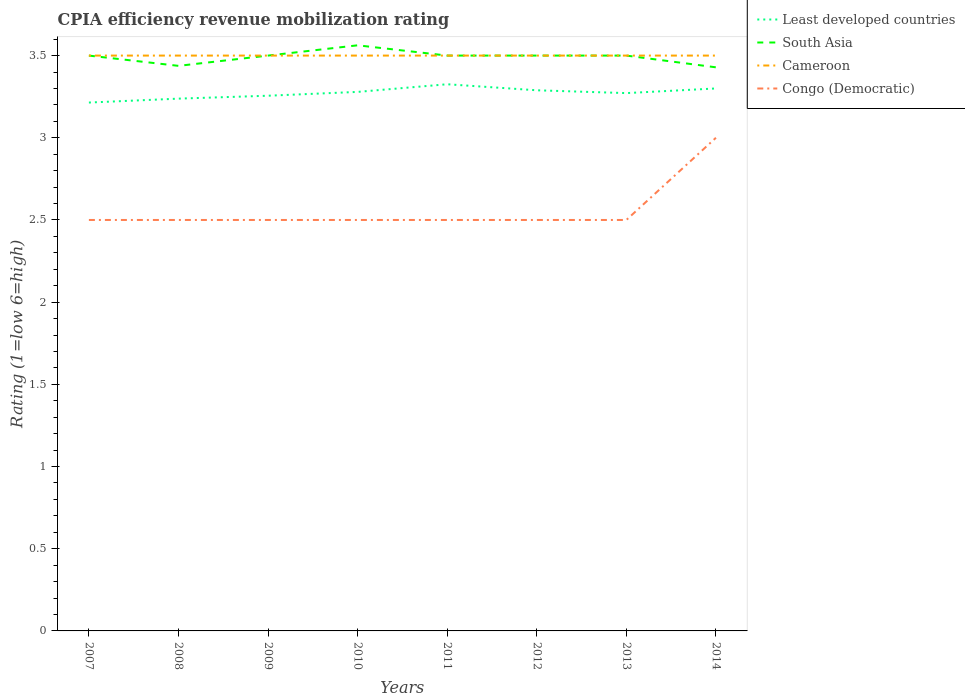Across all years, what is the maximum CPIA rating in Cameroon?
Provide a short and direct response. 3.5. In which year was the CPIA rating in Cameroon maximum?
Ensure brevity in your answer.  2007. What is the total CPIA rating in South Asia in the graph?
Give a very brief answer. 0.06. What is the difference between the highest and the second highest CPIA rating in Least developed countries?
Offer a terse response. 0.11. What is the difference between the highest and the lowest CPIA rating in South Asia?
Keep it short and to the point. 6. Is the CPIA rating in Least developed countries strictly greater than the CPIA rating in Congo (Democratic) over the years?
Provide a succinct answer. No. How many lines are there?
Your answer should be very brief. 4. Does the graph contain any zero values?
Your answer should be very brief. No. How are the legend labels stacked?
Make the answer very short. Vertical. What is the title of the graph?
Make the answer very short. CPIA efficiency revenue mobilization rating. What is the label or title of the X-axis?
Provide a short and direct response. Years. What is the Rating (1=low 6=high) in Least developed countries in 2007?
Give a very brief answer. 3.21. What is the Rating (1=low 6=high) of South Asia in 2007?
Your response must be concise. 3.5. What is the Rating (1=low 6=high) in Cameroon in 2007?
Provide a short and direct response. 3.5. What is the Rating (1=low 6=high) in Congo (Democratic) in 2007?
Make the answer very short. 2.5. What is the Rating (1=low 6=high) in Least developed countries in 2008?
Offer a terse response. 3.24. What is the Rating (1=low 6=high) in South Asia in 2008?
Offer a terse response. 3.44. What is the Rating (1=low 6=high) in Least developed countries in 2009?
Make the answer very short. 3.26. What is the Rating (1=low 6=high) of South Asia in 2009?
Offer a terse response. 3.5. What is the Rating (1=low 6=high) in Least developed countries in 2010?
Offer a terse response. 3.28. What is the Rating (1=low 6=high) in South Asia in 2010?
Your response must be concise. 3.56. What is the Rating (1=low 6=high) of Congo (Democratic) in 2010?
Offer a terse response. 2.5. What is the Rating (1=low 6=high) in Least developed countries in 2011?
Ensure brevity in your answer.  3.33. What is the Rating (1=low 6=high) in South Asia in 2011?
Keep it short and to the point. 3.5. What is the Rating (1=low 6=high) in Cameroon in 2011?
Provide a short and direct response. 3.5. What is the Rating (1=low 6=high) of Congo (Democratic) in 2011?
Make the answer very short. 2.5. What is the Rating (1=low 6=high) of Least developed countries in 2012?
Give a very brief answer. 3.29. What is the Rating (1=low 6=high) in Cameroon in 2012?
Provide a succinct answer. 3.5. What is the Rating (1=low 6=high) of Least developed countries in 2013?
Keep it short and to the point. 3.27. What is the Rating (1=low 6=high) of South Asia in 2013?
Keep it short and to the point. 3.5. What is the Rating (1=low 6=high) in Least developed countries in 2014?
Your response must be concise. 3.3. What is the Rating (1=low 6=high) of South Asia in 2014?
Provide a succinct answer. 3.43. What is the Rating (1=low 6=high) of Cameroon in 2014?
Your answer should be compact. 3.5. What is the Rating (1=low 6=high) in Congo (Democratic) in 2014?
Offer a very short reply. 3. Across all years, what is the maximum Rating (1=low 6=high) of Least developed countries?
Give a very brief answer. 3.33. Across all years, what is the maximum Rating (1=low 6=high) of South Asia?
Your answer should be very brief. 3.56. Across all years, what is the minimum Rating (1=low 6=high) of Least developed countries?
Provide a succinct answer. 3.21. Across all years, what is the minimum Rating (1=low 6=high) of South Asia?
Your answer should be very brief. 3.43. Across all years, what is the minimum Rating (1=low 6=high) in Cameroon?
Offer a terse response. 3.5. What is the total Rating (1=low 6=high) of Least developed countries in the graph?
Your response must be concise. 26.17. What is the total Rating (1=low 6=high) of South Asia in the graph?
Offer a very short reply. 27.93. What is the total Rating (1=low 6=high) of Cameroon in the graph?
Keep it short and to the point. 28. What is the total Rating (1=low 6=high) of Congo (Democratic) in the graph?
Ensure brevity in your answer.  20.5. What is the difference between the Rating (1=low 6=high) of Least developed countries in 2007 and that in 2008?
Keep it short and to the point. -0.02. What is the difference between the Rating (1=low 6=high) in South Asia in 2007 and that in 2008?
Your answer should be compact. 0.06. What is the difference between the Rating (1=low 6=high) of Least developed countries in 2007 and that in 2009?
Ensure brevity in your answer.  -0.04. What is the difference between the Rating (1=low 6=high) in Least developed countries in 2007 and that in 2010?
Your answer should be compact. -0.06. What is the difference between the Rating (1=low 6=high) in South Asia in 2007 and that in 2010?
Offer a very short reply. -0.06. What is the difference between the Rating (1=low 6=high) of Cameroon in 2007 and that in 2010?
Your answer should be very brief. 0. What is the difference between the Rating (1=low 6=high) in Congo (Democratic) in 2007 and that in 2010?
Keep it short and to the point. 0. What is the difference between the Rating (1=low 6=high) in Least developed countries in 2007 and that in 2011?
Offer a terse response. -0.11. What is the difference between the Rating (1=low 6=high) of Cameroon in 2007 and that in 2011?
Provide a succinct answer. 0. What is the difference between the Rating (1=low 6=high) of Congo (Democratic) in 2007 and that in 2011?
Make the answer very short. 0. What is the difference between the Rating (1=low 6=high) in Least developed countries in 2007 and that in 2012?
Give a very brief answer. -0.07. What is the difference between the Rating (1=low 6=high) in South Asia in 2007 and that in 2012?
Make the answer very short. 0. What is the difference between the Rating (1=low 6=high) of Cameroon in 2007 and that in 2012?
Your answer should be compact. 0. What is the difference between the Rating (1=low 6=high) of Congo (Democratic) in 2007 and that in 2012?
Keep it short and to the point. 0. What is the difference between the Rating (1=low 6=high) of Least developed countries in 2007 and that in 2013?
Your response must be concise. -0.06. What is the difference between the Rating (1=low 6=high) in Cameroon in 2007 and that in 2013?
Offer a terse response. 0. What is the difference between the Rating (1=low 6=high) of Congo (Democratic) in 2007 and that in 2013?
Offer a very short reply. 0. What is the difference between the Rating (1=low 6=high) in Least developed countries in 2007 and that in 2014?
Give a very brief answer. -0.09. What is the difference between the Rating (1=low 6=high) of South Asia in 2007 and that in 2014?
Your answer should be very brief. 0.07. What is the difference between the Rating (1=low 6=high) of Cameroon in 2007 and that in 2014?
Keep it short and to the point. 0. What is the difference between the Rating (1=low 6=high) of Least developed countries in 2008 and that in 2009?
Provide a succinct answer. -0.02. What is the difference between the Rating (1=low 6=high) of South Asia in 2008 and that in 2009?
Your answer should be very brief. -0.06. What is the difference between the Rating (1=low 6=high) in Cameroon in 2008 and that in 2009?
Your response must be concise. 0. What is the difference between the Rating (1=low 6=high) in Congo (Democratic) in 2008 and that in 2009?
Ensure brevity in your answer.  0. What is the difference between the Rating (1=low 6=high) in Least developed countries in 2008 and that in 2010?
Provide a short and direct response. -0.04. What is the difference between the Rating (1=low 6=high) of South Asia in 2008 and that in 2010?
Your answer should be very brief. -0.12. What is the difference between the Rating (1=low 6=high) in Least developed countries in 2008 and that in 2011?
Keep it short and to the point. -0.09. What is the difference between the Rating (1=low 6=high) of South Asia in 2008 and that in 2011?
Your response must be concise. -0.06. What is the difference between the Rating (1=low 6=high) of Cameroon in 2008 and that in 2011?
Your response must be concise. 0. What is the difference between the Rating (1=low 6=high) of Congo (Democratic) in 2008 and that in 2011?
Your response must be concise. 0. What is the difference between the Rating (1=low 6=high) of Least developed countries in 2008 and that in 2012?
Your answer should be very brief. -0.05. What is the difference between the Rating (1=low 6=high) in South Asia in 2008 and that in 2012?
Make the answer very short. -0.06. What is the difference between the Rating (1=low 6=high) of Least developed countries in 2008 and that in 2013?
Ensure brevity in your answer.  -0.03. What is the difference between the Rating (1=low 6=high) of South Asia in 2008 and that in 2013?
Provide a short and direct response. -0.06. What is the difference between the Rating (1=low 6=high) of Congo (Democratic) in 2008 and that in 2013?
Your response must be concise. 0. What is the difference between the Rating (1=low 6=high) in Least developed countries in 2008 and that in 2014?
Make the answer very short. -0.06. What is the difference between the Rating (1=low 6=high) in South Asia in 2008 and that in 2014?
Offer a terse response. 0.01. What is the difference between the Rating (1=low 6=high) in Cameroon in 2008 and that in 2014?
Offer a terse response. 0. What is the difference between the Rating (1=low 6=high) of Least developed countries in 2009 and that in 2010?
Provide a short and direct response. -0.02. What is the difference between the Rating (1=low 6=high) in South Asia in 2009 and that in 2010?
Your answer should be compact. -0.06. What is the difference between the Rating (1=low 6=high) in Cameroon in 2009 and that in 2010?
Provide a succinct answer. 0. What is the difference between the Rating (1=low 6=high) in Congo (Democratic) in 2009 and that in 2010?
Your response must be concise. 0. What is the difference between the Rating (1=low 6=high) of Least developed countries in 2009 and that in 2011?
Keep it short and to the point. -0.07. What is the difference between the Rating (1=low 6=high) in Cameroon in 2009 and that in 2011?
Keep it short and to the point. 0. What is the difference between the Rating (1=low 6=high) of Congo (Democratic) in 2009 and that in 2011?
Your answer should be very brief. 0. What is the difference between the Rating (1=low 6=high) of Least developed countries in 2009 and that in 2012?
Provide a short and direct response. -0.03. What is the difference between the Rating (1=low 6=high) in South Asia in 2009 and that in 2012?
Provide a succinct answer. 0. What is the difference between the Rating (1=low 6=high) in Congo (Democratic) in 2009 and that in 2012?
Provide a succinct answer. 0. What is the difference between the Rating (1=low 6=high) of Least developed countries in 2009 and that in 2013?
Ensure brevity in your answer.  -0.02. What is the difference between the Rating (1=low 6=high) in South Asia in 2009 and that in 2013?
Give a very brief answer. 0. What is the difference between the Rating (1=low 6=high) in Congo (Democratic) in 2009 and that in 2013?
Make the answer very short. 0. What is the difference between the Rating (1=low 6=high) of Least developed countries in 2009 and that in 2014?
Your answer should be compact. -0.04. What is the difference between the Rating (1=low 6=high) of South Asia in 2009 and that in 2014?
Offer a terse response. 0.07. What is the difference between the Rating (1=low 6=high) in Least developed countries in 2010 and that in 2011?
Offer a terse response. -0.05. What is the difference between the Rating (1=low 6=high) of South Asia in 2010 and that in 2011?
Make the answer very short. 0.06. What is the difference between the Rating (1=low 6=high) of Congo (Democratic) in 2010 and that in 2011?
Offer a terse response. 0. What is the difference between the Rating (1=low 6=high) in Least developed countries in 2010 and that in 2012?
Your response must be concise. -0.01. What is the difference between the Rating (1=low 6=high) in South Asia in 2010 and that in 2012?
Offer a very short reply. 0.06. What is the difference between the Rating (1=low 6=high) in Congo (Democratic) in 2010 and that in 2012?
Your response must be concise. 0. What is the difference between the Rating (1=low 6=high) in Least developed countries in 2010 and that in 2013?
Keep it short and to the point. 0.01. What is the difference between the Rating (1=low 6=high) in South Asia in 2010 and that in 2013?
Your response must be concise. 0.06. What is the difference between the Rating (1=low 6=high) in Congo (Democratic) in 2010 and that in 2013?
Give a very brief answer. 0. What is the difference between the Rating (1=low 6=high) in Least developed countries in 2010 and that in 2014?
Offer a terse response. -0.02. What is the difference between the Rating (1=low 6=high) of South Asia in 2010 and that in 2014?
Your response must be concise. 0.13. What is the difference between the Rating (1=low 6=high) in Least developed countries in 2011 and that in 2012?
Offer a terse response. 0.04. What is the difference between the Rating (1=low 6=high) in South Asia in 2011 and that in 2012?
Make the answer very short. 0. What is the difference between the Rating (1=low 6=high) in Cameroon in 2011 and that in 2012?
Make the answer very short. 0. What is the difference between the Rating (1=low 6=high) in Least developed countries in 2011 and that in 2013?
Make the answer very short. 0.05. What is the difference between the Rating (1=low 6=high) in Congo (Democratic) in 2011 and that in 2013?
Offer a terse response. 0. What is the difference between the Rating (1=low 6=high) in Least developed countries in 2011 and that in 2014?
Your answer should be very brief. 0.03. What is the difference between the Rating (1=low 6=high) of South Asia in 2011 and that in 2014?
Give a very brief answer. 0.07. What is the difference between the Rating (1=low 6=high) of Cameroon in 2011 and that in 2014?
Provide a succinct answer. 0. What is the difference between the Rating (1=low 6=high) in Least developed countries in 2012 and that in 2013?
Your answer should be very brief. 0.02. What is the difference between the Rating (1=low 6=high) of Cameroon in 2012 and that in 2013?
Provide a short and direct response. 0. What is the difference between the Rating (1=low 6=high) in Congo (Democratic) in 2012 and that in 2013?
Provide a succinct answer. 0. What is the difference between the Rating (1=low 6=high) of Least developed countries in 2012 and that in 2014?
Keep it short and to the point. -0.01. What is the difference between the Rating (1=low 6=high) of South Asia in 2012 and that in 2014?
Make the answer very short. 0.07. What is the difference between the Rating (1=low 6=high) of Congo (Democratic) in 2012 and that in 2014?
Keep it short and to the point. -0.5. What is the difference between the Rating (1=low 6=high) of Least developed countries in 2013 and that in 2014?
Keep it short and to the point. -0.03. What is the difference between the Rating (1=low 6=high) in South Asia in 2013 and that in 2014?
Your response must be concise. 0.07. What is the difference between the Rating (1=low 6=high) in Congo (Democratic) in 2013 and that in 2014?
Provide a succinct answer. -0.5. What is the difference between the Rating (1=low 6=high) of Least developed countries in 2007 and the Rating (1=low 6=high) of South Asia in 2008?
Give a very brief answer. -0.22. What is the difference between the Rating (1=low 6=high) of Least developed countries in 2007 and the Rating (1=low 6=high) of Cameroon in 2008?
Give a very brief answer. -0.29. What is the difference between the Rating (1=low 6=high) of South Asia in 2007 and the Rating (1=low 6=high) of Congo (Democratic) in 2008?
Provide a short and direct response. 1. What is the difference between the Rating (1=low 6=high) in Cameroon in 2007 and the Rating (1=low 6=high) in Congo (Democratic) in 2008?
Give a very brief answer. 1. What is the difference between the Rating (1=low 6=high) in Least developed countries in 2007 and the Rating (1=low 6=high) in South Asia in 2009?
Make the answer very short. -0.29. What is the difference between the Rating (1=low 6=high) in Least developed countries in 2007 and the Rating (1=low 6=high) in Cameroon in 2009?
Offer a very short reply. -0.29. What is the difference between the Rating (1=low 6=high) of South Asia in 2007 and the Rating (1=low 6=high) of Cameroon in 2009?
Offer a terse response. 0. What is the difference between the Rating (1=low 6=high) in Cameroon in 2007 and the Rating (1=low 6=high) in Congo (Democratic) in 2009?
Ensure brevity in your answer.  1. What is the difference between the Rating (1=low 6=high) in Least developed countries in 2007 and the Rating (1=low 6=high) in South Asia in 2010?
Your answer should be very brief. -0.35. What is the difference between the Rating (1=low 6=high) in Least developed countries in 2007 and the Rating (1=low 6=high) in Cameroon in 2010?
Your answer should be very brief. -0.29. What is the difference between the Rating (1=low 6=high) of Least developed countries in 2007 and the Rating (1=low 6=high) of Congo (Democratic) in 2010?
Keep it short and to the point. 0.71. What is the difference between the Rating (1=low 6=high) of Cameroon in 2007 and the Rating (1=low 6=high) of Congo (Democratic) in 2010?
Provide a succinct answer. 1. What is the difference between the Rating (1=low 6=high) in Least developed countries in 2007 and the Rating (1=low 6=high) in South Asia in 2011?
Your answer should be compact. -0.29. What is the difference between the Rating (1=low 6=high) of Least developed countries in 2007 and the Rating (1=low 6=high) of Cameroon in 2011?
Make the answer very short. -0.29. What is the difference between the Rating (1=low 6=high) in Least developed countries in 2007 and the Rating (1=low 6=high) in Congo (Democratic) in 2011?
Keep it short and to the point. 0.71. What is the difference between the Rating (1=low 6=high) of South Asia in 2007 and the Rating (1=low 6=high) of Cameroon in 2011?
Keep it short and to the point. 0. What is the difference between the Rating (1=low 6=high) of South Asia in 2007 and the Rating (1=low 6=high) of Congo (Democratic) in 2011?
Your answer should be very brief. 1. What is the difference between the Rating (1=low 6=high) of Least developed countries in 2007 and the Rating (1=low 6=high) of South Asia in 2012?
Offer a terse response. -0.29. What is the difference between the Rating (1=low 6=high) in Least developed countries in 2007 and the Rating (1=low 6=high) in Cameroon in 2012?
Provide a short and direct response. -0.29. What is the difference between the Rating (1=low 6=high) in South Asia in 2007 and the Rating (1=low 6=high) in Congo (Democratic) in 2012?
Offer a very short reply. 1. What is the difference between the Rating (1=low 6=high) in Least developed countries in 2007 and the Rating (1=low 6=high) in South Asia in 2013?
Your answer should be very brief. -0.29. What is the difference between the Rating (1=low 6=high) in Least developed countries in 2007 and the Rating (1=low 6=high) in Cameroon in 2013?
Your answer should be compact. -0.29. What is the difference between the Rating (1=low 6=high) in Least developed countries in 2007 and the Rating (1=low 6=high) in Congo (Democratic) in 2013?
Provide a succinct answer. 0.71. What is the difference between the Rating (1=low 6=high) in South Asia in 2007 and the Rating (1=low 6=high) in Congo (Democratic) in 2013?
Your answer should be very brief. 1. What is the difference between the Rating (1=low 6=high) of Least developed countries in 2007 and the Rating (1=low 6=high) of South Asia in 2014?
Provide a short and direct response. -0.21. What is the difference between the Rating (1=low 6=high) of Least developed countries in 2007 and the Rating (1=low 6=high) of Cameroon in 2014?
Your response must be concise. -0.29. What is the difference between the Rating (1=low 6=high) in Least developed countries in 2007 and the Rating (1=low 6=high) in Congo (Democratic) in 2014?
Keep it short and to the point. 0.21. What is the difference between the Rating (1=low 6=high) of South Asia in 2007 and the Rating (1=low 6=high) of Cameroon in 2014?
Give a very brief answer. 0. What is the difference between the Rating (1=low 6=high) in South Asia in 2007 and the Rating (1=low 6=high) in Congo (Democratic) in 2014?
Ensure brevity in your answer.  0.5. What is the difference between the Rating (1=low 6=high) in Least developed countries in 2008 and the Rating (1=low 6=high) in South Asia in 2009?
Offer a terse response. -0.26. What is the difference between the Rating (1=low 6=high) of Least developed countries in 2008 and the Rating (1=low 6=high) of Cameroon in 2009?
Ensure brevity in your answer.  -0.26. What is the difference between the Rating (1=low 6=high) of Least developed countries in 2008 and the Rating (1=low 6=high) of Congo (Democratic) in 2009?
Provide a succinct answer. 0.74. What is the difference between the Rating (1=low 6=high) in South Asia in 2008 and the Rating (1=low 6=high) in Cameroon in 2009?
Provide a succinct answer. -0.06. What is the difference between the Rating (1=low 6=high) of Least developed countries in 2008 and the Rating (1=low 6=high) of South Asia in 2010?
Provide a succinct answer. -0.32. What is the difference between the Rating (1=low 6=high) of Least developed countries in 2008 and the Rating (1=low 6=high) of Cameroon in 2010?
Your response must be concise. -0.26. What is the difference between the Rating (1=low 6=high) of Least developed countries in 2008 and the Rating (1=low 6=high) of Congo (Democratic) in 2010?
Your answer should be compact. 0.74. What is the difference between the Rating (1=low 6=high) in South Asia in 2008 and the Rating (1=low 6=high) in Cameroon in 2010?
Offer a very short reply. -0.06. What is the difference between the Rating (1=low 6=high) in South Asia in 2008 and the Rating (1=low 6=high) in Congo (Democratic) in 2010?
Ensure brevity in your answer.  0.94. What is the difference between the Rating (1=low 6=high) of Least developed countries in 2008 and the Rating (1=low 6=high) of South Asia in 2011?
Keep it short and to the point. -0.26. What is the difference between the Rating (1=low 6=high) of Least developed countries in 2008 and the Rating (1=low 6=high) of Cameroon in 2011?
Make the answer very short. -0.26. What is the difference between the Rating (1=low 6=high) in Least developed countries in 2008 and the Rating (1=low 6=high) in Congo (Democratic) in 2011?
Make the answer very short. 0.74. What is the difference between the Rating (1=low 6=high) of South Asia in 2008 and the Rating (1=low 6=high) of Cameroon in 2011?
Provide a succinct answer. -0.06. What is the difference between the Rating (1=low 6=high) in Cameroon in 2008 and the Rating (1=low 6=high) in Congo (Democratic) in 2011?
Keep it short and to the point. 1. What is the difference between the Rating (1=low 6=high) in Least developed countries in 2008 and the Rating (1=low 6=high) in South Asia in 2012?
Your response must be concise. -0.26. What is the difference between the Rating (1=low 6=high) of Least developed countries in 2008 and the Rating (1=low 6=high) of Cameroon in 2012?
Keep it short and to the point. -0.26. What is the difference between the Rating (1=low 6=high) of Least developed countries in 2008 and the Rating (1=low 6=high) of Congo (Democratic) in 2012?
Provide a succinct answer. 0.74. What is the difference between the Rating (1=low 6=high) in South Asia in 2008 and the Rating (1=low 6=high) in Cameroon in 2012?
Your response must be concise. -0.06. What is the difference between the Rating (1=low 6=high) of Cameroon in 2008 and the Rating (1=low 6=high) of Congo (Democratic) in 2012?
Provide a short and direct response. 1. What is the difference between the Rating (1=low 6=high) of Least developed countries in 2008 and the Rating (1=low 6=high) of South Asia in 2013?
Provide a succinct answer. -0.26. What is the difference between the Rating (1=low 6=high) of Least developed countries in 2008 and the Rating (1=low 6=high) of Cameroon in 2013?
Provide a short and direct response. -0.26. What is the difference between the Rating (1=low 6=high) in Least developed countries in 2008 and the Rating (1=low 6=high) in Congo (Democratic) in 2013?
Your answer should be very brief. 0.74. What is the difference between the Rating (1=low 6=high) of South Asia in 2008 and the Rating (1=low 6=high) of Cameroon in 2013?
Offer a terse response. -0.06. What is the difference between the Rating (1=low 6=high) in Least developed countries in 2008 and the Rating (1=low 6=high) in South Asia in 2014?
Give a very brief answer. -0.19. What is the difference between the Rating (1=low 6=high) in Least developed countries in 2008 and the Rating (1=low 6=high) in Cameroon in 2014?
Your answer should be compact. -0.26. What is the difference between the Rating (1=low 6=high) of Least developed countries in 2008 and the Rating (1=low 6=high) of Congo (Democratic) in 2014?
Give a very brief answer. 0.24. What is the difference between the Rating (1=low 6=high) in South Asia in 2008 and the Rating (1=low 6=high) in Cameroon in 2014?
Your answer should be very brief. -0.06. What is the difference between the Rating (1=low 6=high) in South Asia in 2008 and the Rating (1=low 6=high) in Congo (Democratic) in 2014?
Provide a short and direct response. 0.44. What is the difference between the Rating (1=low 6=high) in Least developed countries in 2009 and the Rating (1=low 6=high) in South Asia in 2010?
Offer a very short reply. -0.31. What is the difference between the Rating (1=low 6=high) of Least developed countries in 2009 and the Rating (1=low 6=high) of Cameroon in 2010?
Give a very brief answer. -0.24. What is the difference between the Rating (1=low 6=high) of Least developed countries in 2009 and the Rating (1=low 6=high) of Congo (Democratic) in 2010?
Provide a succinct answer. 0.76. What is the difference between the Rating (1=low 6=high) in South Asia in 2009 and the Rating (1=low 6=high) in Congo (Democratic) in 2010?
Keep it short and to the point. 1. What is the difference between the Rating (1=low 6=high) in Cameroon in 2009 and the Rating (1=low 6=high) in Congo (Democratic) in 2010?
Keep it short and to the point. 1. What is the difference between the Rating (1=low 6=high) in Least developed countries in 2009 and the Rating (1=low 6=high) in South Asia in 2011?
Your answer should be compact. -0.24. What is the difference between the Rating (1=low 6=high) in Least developed countries in 2009 and the Rating (1=low 6=high) in Cameroon in 2011?
Your answer should be compact. -0.24. What is the difference between the Rating (1=low 6=high) in Least developed countries in 2009 and the Rating (1=low 6=high) in Congo (Democratic) in 2011?
Make the answer very short. 0.76. What is the difference between the Rating (1=low 6=high) of South Asia in 2009 and the Rating (1=low 6=high) of Cameroon in 2011?
Provide a succinct answer. 0. What is the difference between the Rating (1=low 6=high) in South Asia in 2009 and the Rating (1=low 6=high) in Congo (Democratic) in 2011?
Give a very brief answer. 1. What is the difference between the Rating (1=low 6=high) in Cameroon in 2009 and the Rating (1=low 6=high) in Congo (Democratic) in 2011?
Your response must be concise. 1. What is the difference between the Rating (1=low 6=high) in Least developed countries in 2009 and the Rating (1=low 6=high) in South Asia in 2012?
Provide a short and direct response. -0.24. What is the difference between the Rating (1=low 6=high) of Least developed countries in 2009 and the Rating (1=low 6=high) of Cameroon in 2012?
Provide a succinct answer. -0.24. What is the difference between the Rating (1=low 6=high) in Least developed countries in 2009 and the Rating (1=low 6=high) in Congo (Democratic) in 2012?
Offer a very short reply. 0.76. What is the difference between the Rating (1=low 6=high) in Least developed countries in 2009 and the Rating (1=low 6=high) in South Asia in 2013?
Make the answer very short. -0.24. What is the difference between the Rating (1=low 6=high) of Least developed countries in 2009 and the Rating (1=low 6=high) of Cameroon in 2013?
Offer a terse response. -0.24. What is the difference between the Rating (1=low 6=high) in Least developed countries in 2009 and the Rating (1=low 6=high) in Congo (Democratic) in 2013?
Give a very brief answer. 0.76. What is the difference between the Rating (1=low 6=high) in South Asia in 2009 and the Rating (1=low 6=high) in Cameroon in 2013?
Give a very brief answer. 0. What is the difference between the Rating (1=low 6=high) in Cameroon in 2009 and the Rating (1=low 6=high) in Congo (Democratic) in 2013?
Offer a terse response. 1. What is the difference between the Rating (1=low 6=high) in Least developed countries in 2009 and the Rating (1=low 6=high) in South Asia in 2014?
Your response must be concise. -0.17. What is the difference between the Rating (1=low 6=high) of Least developed countries in 2009 and the Rating (1=low 6=high) of Cameroon in 2014?
Provide a succinct answer. -0.24. What is the difference between the Rating (1=low 6=high) in Least developed countries in 2009 and the Rating (1=low 6=high) in Congo (Democratic) in 2014?
Provide a short and direct response. 0.26. What is the difference between the Rating (1=low 6=high) in South Asia in 2009 and the Rating (1=low 6=high) in Cameroon in 2014?
Ensure brevity in your answer.  0. What is the difference between the Rating (1=low 6=high) of Least developed countries in 2010 and the Rating (1=low 6=high) of South Asia in 2011?
Your answer should be very brief. -0.22. What is the difference between the Rating (1=low 6=high) in Least developed countries in 2010 and the Rating (1=low 6=high) in Cameroon in 2011?
Keep it short and to the point. -0.22. What is the difference between the Rating (1=low 6=high) of Least developed countries in 2010 and the Rating (1=low 6=high) of Congo (Democratic) in 2011?
Give a very brief answer. 0.78. What is the difference between the Rating (1=low 6=high) in South Asia in 2010 and the Rating (1=low 6=high) in Cameroon in 2011?
Make the answer very short. 0.06. What is the difference between the Rating (1=low 6=high) of Least developed countries in 2010 and the Rating (1=low 6=high) of South Asia in 2012?
Provide a succinct answer. -0.22. What is the difference between the Rating (1=low 6=high) in Least developed countries in 2010 and the Rating (1=low 6=high) in Cameroon in 2012?
Offer a very short reply. -0.22. What is the difference between the Rating (1=low 6=high) in Least developed countries in 2010 and the Rating (1=low 6=high) in Congo (Democratic) in 2012?
Keep it short and to the point. 0.78. What is the difference between the Rating (1=low 6=high) in South Asia in 2010 and the Rating (1=low 6=high) in Cameroon in 2012?
Offer a terse response. 0.06. What is the difference between the Rating (1=low 6=high) in South Asia in 2010 and the Rating (1=low 6=high) in Congo (Democratic) in 2012?
Keep it short and to the point. 1.06. What is the difference between the Rating (1=low 6=high) in Least developed countries in 2010 and the Rating (1=low 6=high) in South Asia in 2013?
Your response must be concise. -0.22. What is the difference between the Rating (1=low 6=high) in Least developed countries in 2010 and the Rating (1=low 6=high) in Cameroon in 2013?
Provide a succinct answer. -0.22. What is the difference between the Rating (1=low 6=high) in Least developed countries in 2010 and the Rating (1=low 6=high) in Congo (Democratic) in 2013?
Offer a very short reply. 0.78. What is the difference between the Rating (1=low 6=high) of South Asia in 2010 and the Rating (1=low 6=high) of Cameroon in 2013?
Your answer should be very brief. 0.06. What is the difference between the Rating (1=low 6=high) in South Asia in 2010 and the Rating (1=low 6=high) in Congo (Democratic) in 2013?
Keep it short and to the point. 1.06. What is the difference between the Rating (1=low 6=high) of Least developed countries in 2010 and the Rating (1=low 6=high) of South Asia in 2014?
Provide a succinct answer. -0.15. What is the difference between the Rating (1=low 6=high) in Least developed countries in 2010 and the Rating (1=low 6=high) in Cameroon in 2014?
Provide a short and direct response. -0.22. What is the difference between the Rating (1=low 6=high) of Least developed countries in 2010 and the Rating (1=low 6=high) of Congo (Democratic) in 2014?
Your answer should be very brief. 0.28. What is the difference between the Rating (1=low 6=high) of South Asia in 2010 and the Rating (1=low 6=high) of Cameroon in 2014?
Give a very brief answer. 0.06. What is the difference between the Rating (1=low 6=high) in South Asia in 2010 and the Rating (1=low 6=high) in Congo (Democratic) in 2014?
Provide a succinct answer. 0.56. What is the difference between the Rating (1=low 6=high) of Least developed countries in 2011 and the Rating (1=low 6=high) of South Asia in 2012?
Keep it short and to the point. -0.17. What is the difference between the Rating (1=low 6=high) of Least developed countries in 2011 and the Rating (1=low 6=high) of Cameroon in 2012?
Make the answer very short. -0.17. What is the difference between the Rating (1=low 6=high) in Least developed countries in 2011 and the Rating (1=low 6=high) in Congo (Democratic) in 2012?
Offer a terse response. 0.83. What is the difference between the Rating (1=low 6=high) of South Asia in 2011 and the Rating (1=low 6=high) of Cameroon in 2012?
Your response must be concise. 0. What is the difference between the Rating (1=low 6=high) in South Asia in 2011 and the Rating (1=low 6=high) in Congo (Democratic) in 2012?
Your answer should be compact. 1. What is the difference between the Rating (1=low 6=high) of Least developed countries in 2011 and the Rating (1=low 6=high) of South Asia in 2013?
Make the answer very short. -0.17. What is the difference between the Rating (1=low 6=high) of Least developed countries in 2011 and the Rating (1=low 6=high) of Cameroon in 2013?
Give a very brief answer. -0.17. What is the difference between the Rating (1=low 6=high) of Least developed countries in 2011 and the Rating (1=low 6=high) of Congo (Democratic) in 2013?
Make the answer very short. 0.83. What is the difference between the Rating (1=low 6=high) of Least developed countries in 2011 and the Rating (1=low 6=high) of South Asia in 2014?
Your answer should be very brief. -0.1. What is the difference between the Rating (1=low 6=high) of Least developed countries in 2011 and the Rating (1=low 6=high) of Cameroon in 2014?
Offer a very short reply. -0.17. What is the difference between the Rating (1=low 6=high) in Least developed countries in 2011 and the Rating (1=low 6=high) in Congo (Democratic) in 2014?
Give a very brief answer. 0.33. What is the difference between the Rating (1=low 6=high) in Least developed countries in 2012 and the Rating (1=low 6=high) in South Asia in 2013?
Provide a succinct answer. -0.21. What is the difference between the Rating (1=low 6=high) of Least developed countries in 2012 and the Rating (1=low 6=high) of Cameroon in 2013?
Provide a short and direct response. -0.21. What is the difference between the Rating (1=low 6=high) of Least developed countries in 2012 and the Rating (1=low 6=high) of Congo (Democratic) in 2013?
Offer a terse response. 0.79. What is the difference between the Rating (1=low 6=high) in South Asia in 2012 and the Rating (1=low 6=high) in Cameroon in 2013?
Your answer should be very brief. 0. What is the difference between the Rating (1=low 6=high) of Cameroon in 2012 and the Rating (1=low 6=high) of Congo (Democratic) in 2013?
Provide a short and direct response. 1. What is the difference between the Rating (1=low 6=high) of Least developed countries in 2012 and the Rating (1=low 6=high) of South Asia in 2014?
Give a very brief answer. -0.14. What is the difference between the Rating (1=low 6=high) of Least developed countries in 2012 and the Rating (1=low 6=high) of Cameroon in 2014?
Your answer should be compact. -0.21. What is the difference between the Rating (1=low 6=high) of Least developed countries in 2012 and the Rating (1=low 6=high) of Congo (Democratic) in 2014?
Your response must be concise. 0.29. What is the difference between the Rating (1=low 6=high) of Least developed countries in 2013 and the Rating (1=low 6=high) of South Asia in 2014?
Keep it short and to the point. -0.16. What is the difference between the Rating (1=low 6=high) in Least developed countries in 2013 and the Rating (1=low 6=high) in Cameroon in 2014?
Give a very brief answer. -0.23. What is the difference between the Rating (1=low 6=high) of Least developed countries in 2013 and the Rating (1=low 6=high) of Congo (Democratic) in 2014?
Keep it short and to the point. 0.27. What is the difference between the Rating (1=low 6=high) of South Asia in 2013 and the Rating (1=low 6=high) of Cameroon in 2014?
Your answer should be very brief. 0. What is the difference between the Rating (1=low 6=high) in South Asia in 2013 and the Rating (1=low 6=high) in Congo (Democratic) in 2014?
Give a very brief answer. 0.5. What is the difference between the Rating (1=low 6=high) of Cameroon in 2013 and the Rating (1=low 6=high) of Congo (Democratic) in 2014?
Your answer should be compact. 0.5. What is the average Rating (1=low 6=high) of Least developed countries per year?
Offer a terse response. 3.27. What is the average Rating (1=low 6=high) of South Asia per year?
Your response must be concise. 3.49. What is the average Rating (1=low 6=high) of Congo (Democratic) per year?
Ensure brevity in your answer.  2.56. In the year 2007, what is the difference between the Rating (1=low 6=high) of Least developed countries and Rating (1=low 6=high) of South Asia?
Give a very brief answer. -0.29. In the year 2007, what is the difference between the Rating (1=low 6=high) of Least developed countries and Rating (1=low 6=high) of Cameroon?
Provide a succinct answer. -0.29. In the year 2007, what is the difference between the Rating (1=low 6=high) of Least developed countries and Rating (1=low 6=high) of Congo (Democratic)?
Ensure brevity in your answer.  0.71. In the year 2007, what is the difference between the Rating (1=low 6=high) of South Asia and Rating (1=low 6=high) of Cameroon?
Your response must be concise. 0. In the year 2007, what is the difference between the Rating (1=low 6=high) in Cameroon and Rating (1=low 6=high) in Congo (Democratic)?
Provide a short and direct response. 1. In the year 2008, what is the difference between the Rating (1=low 6=high) in Least developed countries and Rating (1=low 6=high) in South Asia?
Offer a very short reply. -0.2. In the year 2008, what is the difference between the Rating (1=low 6=high) of Least developed countries and Rating (1=low 6=high) of Cameroon?
Give a very brief answer. -0.26. In the year 2008, what is the difference between the Rating (1=low 6=high) in Least developed countries and Rating (1=low 6=high) in Congo (Democratic)?
Your response must be concise. 0.74. In the year 2008, what is the difference between the Rating (1=low 6=high) in South Asia and Rating (1=low 6=high) in Cameroon?
Your answer should be compact. -0.06. In the year 2008, what is the difference between the Rating (1=low 6=high) in South Asia and Rating (1=low 6=high) in Congo (Democratic)?
Provide a succinct answer. 0.94. In the year 2009, what is the difference between the Rating (1=low 6=high) in Least developed countries and Rating (1=low 6=high) in South Asia?
Offer a very short reply. -0.24. In the year 2009, what is the difference between the Rating (1=low 6=high) of Least developed countries and Rating (1=low 6=high) of Cameroon?
Your response must be concise. -0.24. In the year 2009, what is the difference between the Rating (1=low 6=high) of Least developed countries and Rating (1=low 6=high) of Congo (Democratic)?
Give a very brief answer. 0.76. In the year 2009, what is the difference between the Rating (1=low 6=high) of South Asia and Rating (1=low 6=high) of Congo (Democratic)?
Keep it short and to the point. 1. In the year 2009, what is the difference between the Rating (1=low 6=high) of Cameroon and Rating (1=low 6=high) of Congo (Democratic)?
Make the answer very short. 1. In the year 2010, what is the difference between the Rating (1=low 6=high) in Least developed countries and Rating (1=low 6=high) in South Asia?
Ensure brevity in your answer.  -0.28. In the year 2010, what is the difference between the Rating (1=low 6=high) in Least developed countries and Rating (1=low 6=high) in Cameroon?
Keep it short and to the point. -0.22. In the year 2010, what is the difference between the Rating (1=low 6=high) of Least developed countries and Rating (1=low 6=high) of Congo (Democratic)?
Give a very brief answer. 0.78. In the year 2010, what is the difference between the Rating (1=low 6=high) of South Asia and Rating (1=low 6=high) of Cameroon?
Your response must be concise. 0.06. In the year 2010, what is the difference between the Rating (1=low 6=high) in South Asia and Rating (1=low 6=high) in Congo (Democratic)?
Provide a short and direct response. 1.06. In the year 2011, what is the difference between the Rating (1=low 6=high) of Least developed countries and Rating (1=low 6=high) of South Asia?
Make the answer very short. -0.17. In the year 2011, what is the difference between the Rating (1=low 6=high) in Least developed countries and Rating (1=low 6=high) in Cameroon?
Provide a short and direct response. -0.17. In the year 2011, what is the difference between the Rating (1=low 6=high) of Least developed countries and Rating (1=low 6=high) of Congo (Democratic)?
Your response must be concise. 0.83. In the year 2011, what is the difference between the Rating (1=low 6=high) in South Asia and Rating (1=low 6=high) in Cameroon?
Offer a terse response. 0. In the year 2011, what is the difference between the Rating (1=low 6=high) in South Asia and Rating (1=low 6=high) in Congo (Democratic)?
Offer a terse response. 1. In the year 2012, what is the difference between the Rating (1=low 6=high) in Least developed countries and Rating (1=low 6=high) in South Asia?
Your answer should be compact. -0.21. In the year 2012, what is the difference between the Rating (1=low 6=high) of Least developed countries and Rating (1=low 6=high) of Cameroon?
Provide a short and direct response. -0.21. In the year 2012, what is the difference between the Rating (1=low 6=high) in Least developed countries and Rating (1=low 6=high) in Congo (Democratic)?
Your answer should be very brief. 0.79. In the year 2013, what is the difference between the Rating (1=low 6=high) of Least developed countries and Rating (1=low 6=high) of South Asia?
Your answer should be compact. -0.23. In the year 2013, what is the difference between the Rating (1=low 6=high) in Least developed countries and Rating (1=low 6=high) in Cameroon?
Provide a short and direct response. -0.23. In the year 2013, what is the difference between the Rating (1=low 6=high) of Least developed countries and Rating (1=low 6=high) of Congo (Democratic)?
Offer a terse response. 0.77. In the year 2013, what is the difference between the Rating (1=low 6=high) of South Asia and Rating (1=low 6=high) of Cameroon?
Ensure brevity in your answer.  0. In the year 2013, what is the difference between the Rating (1=low 6=high) of South Asia and Rating (1=low 6=high) of Congo (Democratic)?
Provide a succinct answer. 1. In the year 2013, what is the difference between the Rating (1=low 6=high) in Cameroon and Rating (1=low 6=high) in Congo (Democratic)?
Make the answer very short. 1. In the year 2014, what is the difference between the Rating (1=low 6=high) of Least developed countries and Rating (1=low 6=high) of South Asia?
Provide a short and direct response. -0.13. In the year 2014, what is the difference between the Rating (1=low 6=high) of Least developed countries and Rating (1=low 6=high) of Cameroon?
Your answer should be compact. -0.2. In the year 2014, what is the difference between the Rating (1=low 6=high) of South Asia and Rating (1=low 6=high) of Cameroon?
Provide a short and direct response. -0.07. In the year 2014, what is the difference between the Rating (1=low 6=high) of South Asia and Rating (1=low 6=high) of Congo (Democratic)?
Ensure brevity in your answer.  0.43. What is the ratio of the Rating (1=low 6=high) in South Asia in 2007 to that in 2008?
Make the answer very short. 1.02. What is the ratio of the Rating (1=low 6=high) in Cameroon in 2007 to that in 2008?
Your response must be concise. 1. What is the ratio of the Rating (1=low 6=high) in Congo (Democratic) in 2007 to that in 2008?
Offer a terse response. 1. What is the ratio of the Rating (1=low 6=high) in Least developed countries in 2007 to that in 2009?
Provide a short and direct response. 0.99. What is the ratio of the Rating (1=low 6=high) in Cameroon in 2007 to that in 2009?
Provide a succinct answer. 1. What is the ratio of the Rating (1=low 6=high) of Congo (Democratic) in 2007 to that in 2009?
Your answer should be very brief. 1. What is the ratio of the Rating (1=low 6=high) in Least developed countries in 2007 to that in 2010?
Offer a very short reply. 0.98. What is the ratio of the Rating (1=low 6=high) in South Asia in 2007 to that in 2010?
Offer a terse response. 0.98. What is the ratio of the Rating (1=low 6=high) of Cameroon in 2007 to that in 2010?
Provide a short and direct response. 1. What is the ratio of the Rating (1=low 6=high) of Congo (Democratic) in 2007 to that in 2010?
Ensure brevity in your answer.  1. What is the ratio of the Rating (1=low 6=high) of Least developed countries in 2007 to that in 2011?
Provide a succinct answer. 0.97. What is the ratio of the Rating (1=low 6=high) of Least developed countries in 2007 to that in 2012?
Give a very brief answer. 0.98. What is the ratio of the Rating (1=low 6=high) in Cameroon in 2007 to that in 2012?
Offer a terse response. 1. What is the ratio of the Rating (1=low 6=high) in Congo (Democratic) in 2007 to that in 2012?
Make the answer very short. 1. What is the ratio of the Rating (1=low 6=high) in Least developed countries in 2007 to that in 2013?
Your answer should be compact. 0.98. What is the ratio of the Rating (1=low 6=high) of South Asia in 2007 to that in 2013?
Provide a short and direct response. 1. What is the ratio of the Rating (1=low 6=high) of Congo (Democratic) in 2007 to that in 2013?
Offer a very short reply. 1. What is the ratio of the Rating (1=low 6=high) of South Asia in 2007 to that in 2014?
Give a very brief answer. 1.02. What is the ratio of the Rating (1=low 6=high) of South Asia in 2008 to that in 2009?
Offer a very short reply. 0.98. What is the ratio of the Rating (1=low 6=high) in Cameroon in 2008 to that in 2009?
Offer a very short reply. 1. What is the ratio of the Rating (1=low 6=high) of Congo (Democratic) in 2008 to that in 2009?
Make the answer very short. 1. What is the ratio of the Rating (1=low 6=high) in Least developed countries in 2008 to that in 2010?
Provide a succinct answer. 0.99. What is the ratio of the Rating (1=low 6=high) of South Asia in 2008 to that in 2010?
Provide a succinct answer. 0.96. What is the ratio of the Rating (1=low 6=high) of Cameroon in 2008 to that in 2010?
Your answer should be compact. 1. What is the ratio of the Rating (1=low 6=high) in Congo (Democratic) in 2008 to that in 2010?
Make the answer very short. 1. What is the ratio of the Rating (1=low 6=high) in Least developed countries in 2008 to that in 2011?
Your response must be concise. 0.97. What is the ratio of the Rating (1=low 6=high) of South Asia in 2008 to that in 2011?
Offer a terse response. 0.98. What is the ratio of the Rating (1=low 6=high) in Cameroon in 2008 to that in 2011?
Offer a terse response. 1. What is the ratio of the Rating (1=low 6=high) in Congo (Democratic) in 2008 to that in 2011?
Your answer should be compact. 1. What is the ratio of the Rating (1=low 6=high) of Least developed countries in 2008 to that in 2012?
Your answer should be very brief. 0.98. What is the ratio of the Rating (1=low 6=high) of South Asia in 2008 to that in 2012?
Keep it short and to the point. 0.98. What is the ratio of the Rating (1=low 6=high) in Least developed countries in 2008 to that in 2013?
Offer a very short reply. 0.99. What is the ratio of the Rating (1=low 6=high) in South Asia in 2008 to that in 2013?
Your answer should be very brief. 0.98. What is the ratio of the Rating (1=low 6=high) in Cameroon in 2008 to that in 2013?
Your answer should be compact. 1. What is the ratio of the Rating (1=low 6=high) in Congo (Democratic) in 2008 to that in 2013?
Offer a terse response. 1. What is the ratio of the Rating (1=low 6=high) in Least developed countries in 2008 to that in 2014?
Your answer should be very brief. 0.98. What is the ratio of the Rating (1=low 6=high) in South Asia in 2008 to that in 2014?
Give a very brief answer. 1. What is the ratio of the Rating (1=low 6=high) of Cameroon in 2008 to that in 2014?
Keep it short and to the point. 1. What is the ratio of the Rating (1=low 6=high) of Least developed countries in 2009 to that in 2010?
Ensure brevity in your answer.  0.99. What is the ratio of the Rating (1=low 6=high) of South Asia in 2009 to that in 2010?
Offer a very short reply. 0.98. What is the ratio of the Rating (1=low 6=high) in Congo (Democratic) in 2009 to that in 2010?
Your answer should be compact. 1. What is the ratio of the Rating (1=low 6=high) in Cameroon in 2009 to that in 2011?
Provide a succinct answer. 1. What is the ratio of the Rating (1=low 6=high) of Congo (Democratic) in 2009 to that in 2012?
Provide a short and direct response. 1. What is the ratio of the Rating (1=low 6=high) of South Asia in 2009 to that in 2013?
Your answer should be compact. 1. What is the ratio of the Rating (1=low 6=high) in Least developed countries in 2009 to that in 2014?
Keep it short and to the point. 0.99. What is the ratio of the Rating (1=low 6=high) in South Asia in 2009 to that in 2014?
Offer a terse response. 1.02. What is the ratio of the Rating (1=low 6=high) in Congo (Democratic) in 2009 to that in 2014?
Your response must be concise. 0.83. What is the ratio of the Rating (1=low 6=high) in Least developed countries in 2010 to that in 2011?
Provide a succinct answer. 0.99. What is the ratio of the Rating (1=low 6=high) in South Asia in 2010 to that in 2011?
Your answer should be very brief. 1.02. What is the ratio of the Rating (1=low 6=high) of Cameroon in 2010 to that in 2011?
Keep it short and to the point. 1. What is the ratio of the Rating (1=low 6=high) in Congo (Democratic) in 2010 to that in 2011?
Make the answer very short. 1. What is the ratio of the Rating (1=low 6=high) of South Asia in 2010 to that in 2012?
Ensure brevity in your answer.  1.02. What is the ratio of the Rating (1=low 6=high) of Congo (Democratic) in 2010 to that in 2012?
Ensure brevity in your answer.  1. What is the ratio of the Rating (1=low 6=high) in South Asia in 2010 to that in 2013?
Keep it short and to the point. 1.02. What is the ratio of the Rating (1=low 6=high) in Congo (Democratic) in 2010 to that in 2013?
Your response must be concise. 1. What is the ratio of the Rating (1=low 6=high) in Least developed countries in 2010 to that in 2014?
Give a very brief answer. 0.99. What is the ratio of the Rating (1=low 6=high) in South Asia in 2010 to that in 2014?
Your answer should be compact. 1.04. What is the ratio of the Rating (1=low 6=high) of Congo (Democratic) in 2010 to that in 2014?
Offer a terse response. 0.83. What is the ratio of the Rating (1=low 6=high) of Least developed countries in 2011 to that in 2012?
Ensure brevity in your answer.  1.01. What is the ratio of the Rating (1=low 6=high) in South Asia in 2011 to that in 2012?
Offer a terse response. 1. What is the ratio of the Rating (1=low 6=high) in Cameroon in 2011 to that in 2012?
Your answer should be very brief. 1. What is the ratio of the Rating (1=low 6=high) of Congo (Democratic) in 2011 to that in 2012?
Your answer should be very brief. 1. What is the ratio of the Rating (1=low 6=high) of Least developed countries in 2011 to that in 2013?
Give a very brief answer. 1.02. What is the ratio of the Rating (1=low 6=high) of Cameroon in 2011 to that in 2013?
Provide a short and direct response. 1. What is the ratio of the Rating (1=low 6=high) of Congo (Democratic) in 2011 to that in 2013?
Ensure brevity in your answer.  1. What is the ratio of the Rating (1=low 6=high) of South Asia in 2011 to that in 2014?
Ensure brevity in your answer.  1.02. What is the ratio of the Rating (1=low 6=high) of Cameroon in 2011 to that in 2014?
Your answer should be very brief. 1. What is the ratio of the Rating (1=low 6=high) in Congo (Democratic) in 2011 to that in 2014?
Offer a very short reply. 0.83. What is the ratio of the Rating (1=low 6=high) of Congo (Democratic) in 2012 to that in 2013?
Ensure brevity in your answer.  1. What is the ratio of the Rating (1=low 6=high) of South Asia in 2012 to that in 2014?
Provide a succinct answer. 1.02. What is the ratio of the Rating (1=low 6=high) of Cameroon in 2012 to that in 2014?
Your answer should be very brief. 1. What is the ratio of the Rating (1=low 6=high) of Congo (Democratic) in 2012 to that in 2014?
Provide a succinct answer. 0.83. What is the ratio of the Rating (1=low 6=high) of South Asia in 2013 to that in 2014?
Your response must be concise. 1.02. What is the ratio of the Rating (1=low 6=high) in Congo (Democratic) in 2013 to that in 2014?
Give a very brief answer. 0.83. What is the difference between the highest and the second highest Rating (1=low 6=high) in Least developed countries?
Your answer should be very brief. 0.03. What is the difference between the highest and the second highest Rating (1=low 6=high) of South Asia?
Offer a very short reply. 0.06. What is the difference between the highest and the lowest Rating (1=low 6=high) in Least developed countries?
Offer a terse response. 0.11. What is the difference between the highest and the lowest Rating (1=low 6=high) in South Asia?
Keep it short and to the point. 0.13. What is the difference between the highest and the lowest Rating (1=low 6=high) of Congo (Democratic)?
Give a very brief answer. 0.5. 